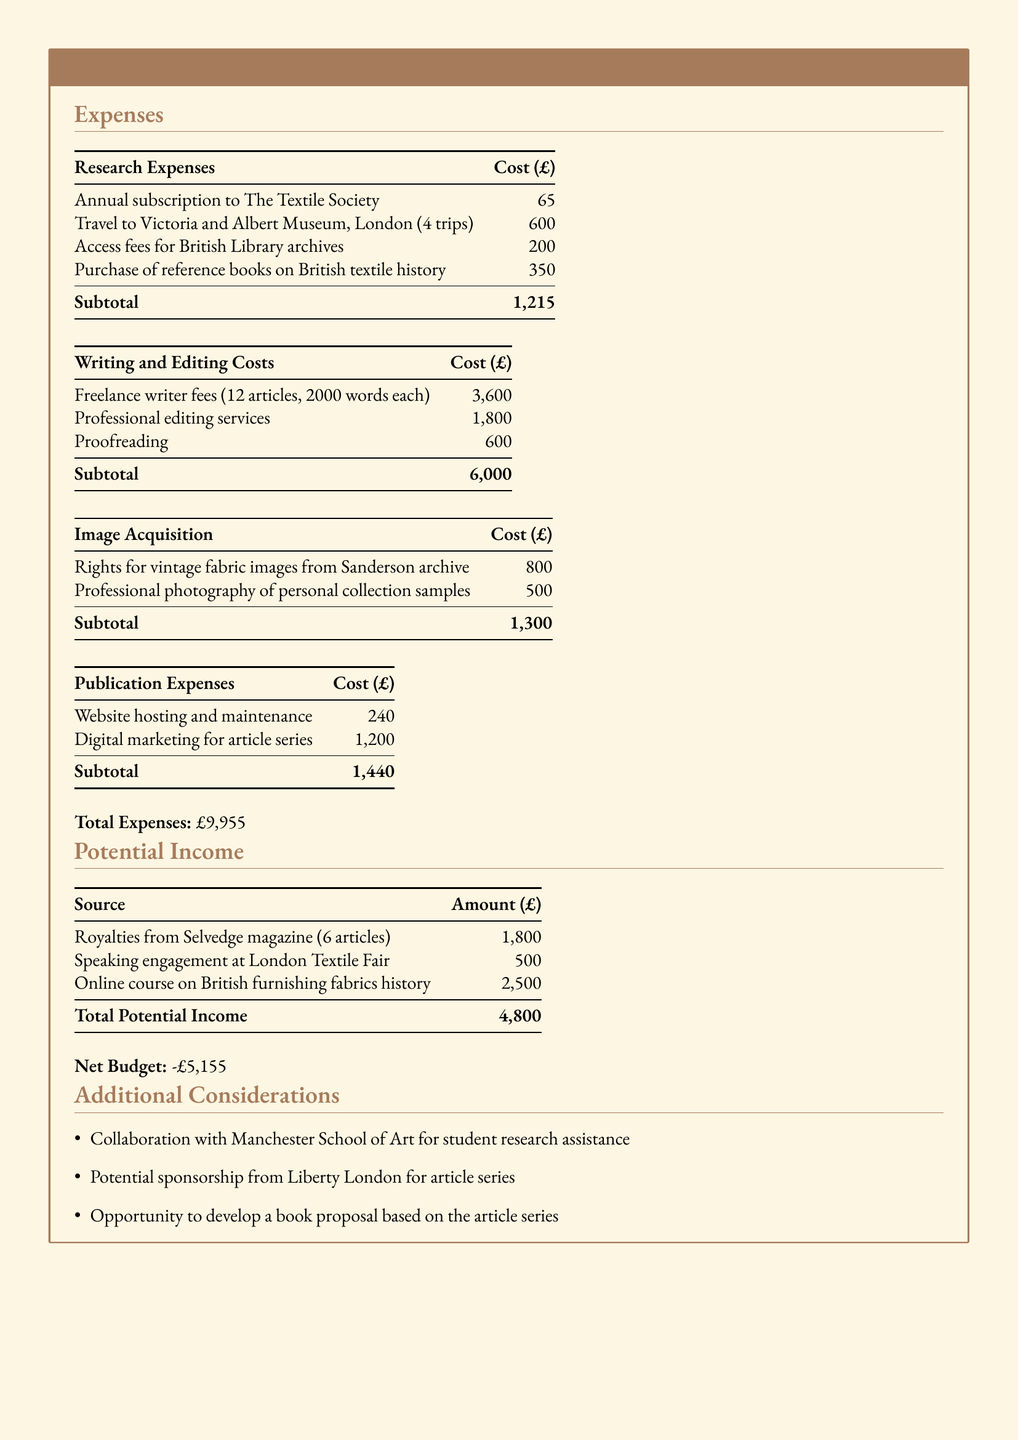What is the total amount for research expenses? The total for research expenses is found by adding the costs listed in the research expenses section, which is £65 + £600 + £200 + £350 = £1,215.
Answer: £1,215 How many articles are included in the freelance writer fees? The number of articles is explicitly stated in the writing and editing costs section, which mentions fees for 12 articles.
Answer: 12 What is the total cost for image acquisition? The total cost for image acquisition is calculated by adding the two specified costs in that section, which is £800 + £500 = £1,300.
Answer: £1,300 What is the total potential income from royalties? The potential income from royalties is explicitly mentioned in the potential income section, which states it is £1,800.
Answer: £1,800 What is the net budget? The net budget is mentioned clearly at the end of the expenses and income calculations, which is derived from total expenses minus total income, resulting in -£5,155.
Answer: -£5,155 What is the cost for digital marketing? The cost for digital marketing is listed under publication expenses, which is £1,200.
Answer: £1,200 What kind of support is mentioned under additional considerations? The additional consideration mentioned is "Collaboration with Manchester School of Art for student research assistance."
Answer: Collaboration with Manchester School of Art How many trips to the Victoria and Albert Museum are planned? The document states that there are 4 trips planned to the Victoria and Albert Museum in the research expenses section.
Answer: 4 trips What is the amount allocated for proofreading? The amount for proofreading is specifically mentioned in the writing and editing costs, which is £600.
Answer: £600 